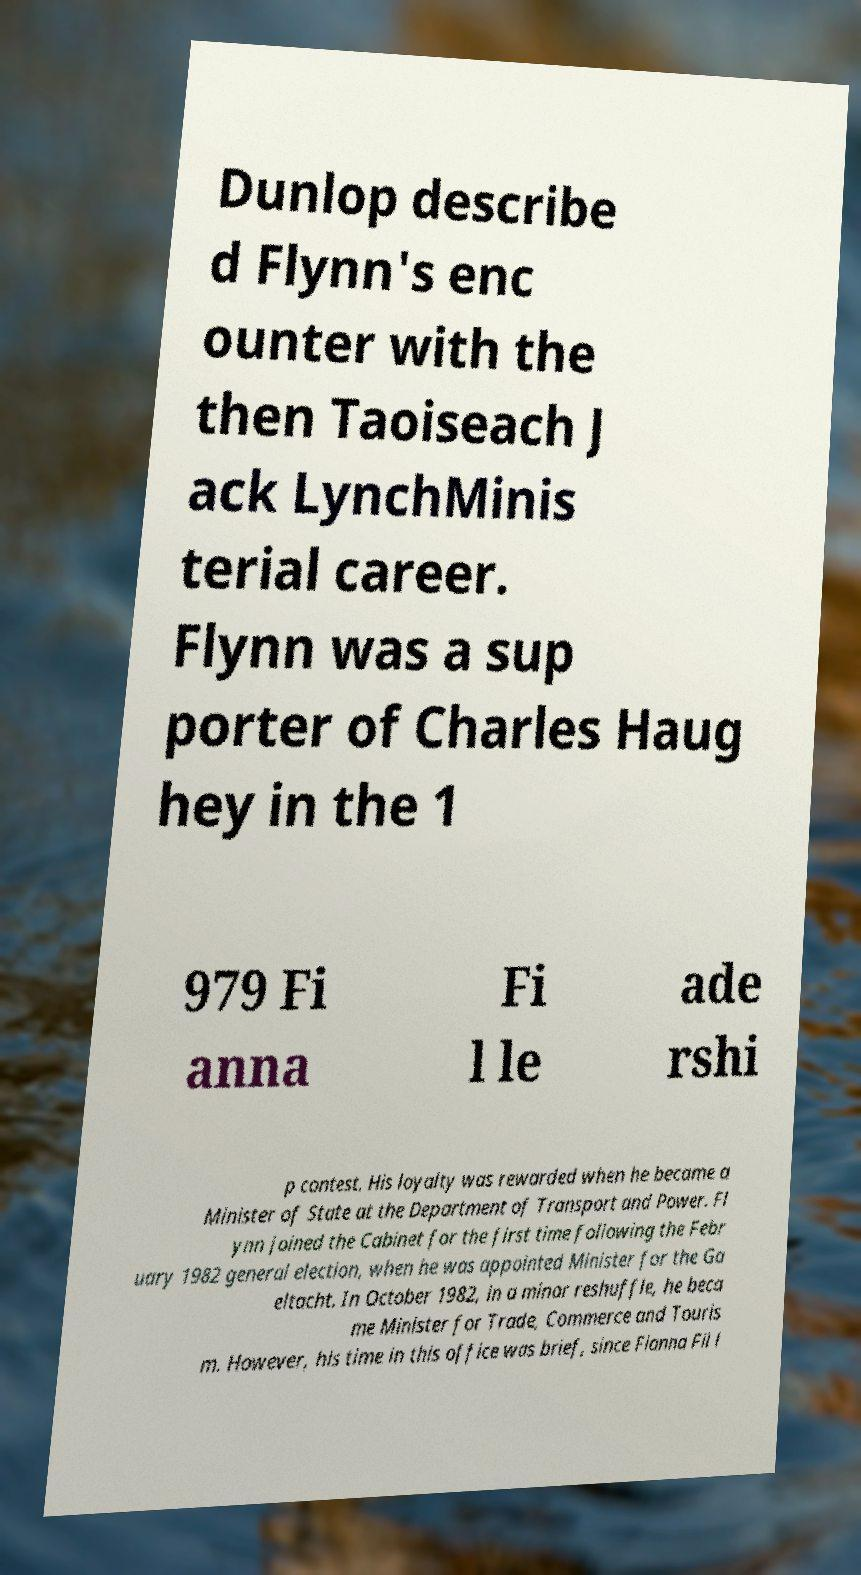I need the written content from this picture converted into text. Can you do that? Dunlop describe d Flynn's enc ounter with the then Taoiseach J ack LynchMinis terial career. Flynn was a sup porter of Charles Haug hey in the 1 979 Fi anna Fi l le ade rshi p contest. His loyalty was rewarded when he became a Minister of State at the Department of Transport and Power. Fl ynn joined the Cabinet for the first time following the Febr uary 1982 general election, when he was appointed Minister for the Ga eltacht. In October 1982, in a minor reshuffle, he beca me Minister for Trade, Commerce and Touris m. However, his time in this office was brief, since Fianna Fil l 